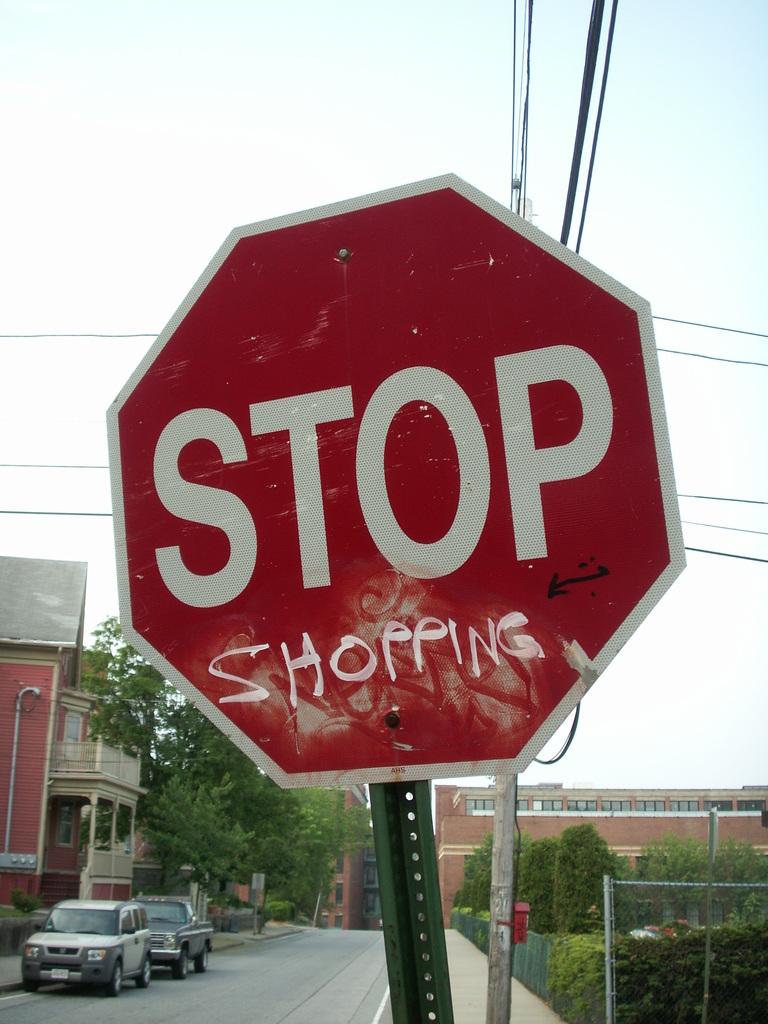What is spray painted on the stop sign?
Your answer should be very brief. Shopping. What kind of sign is this?
Your answer should be compact. Stop. 